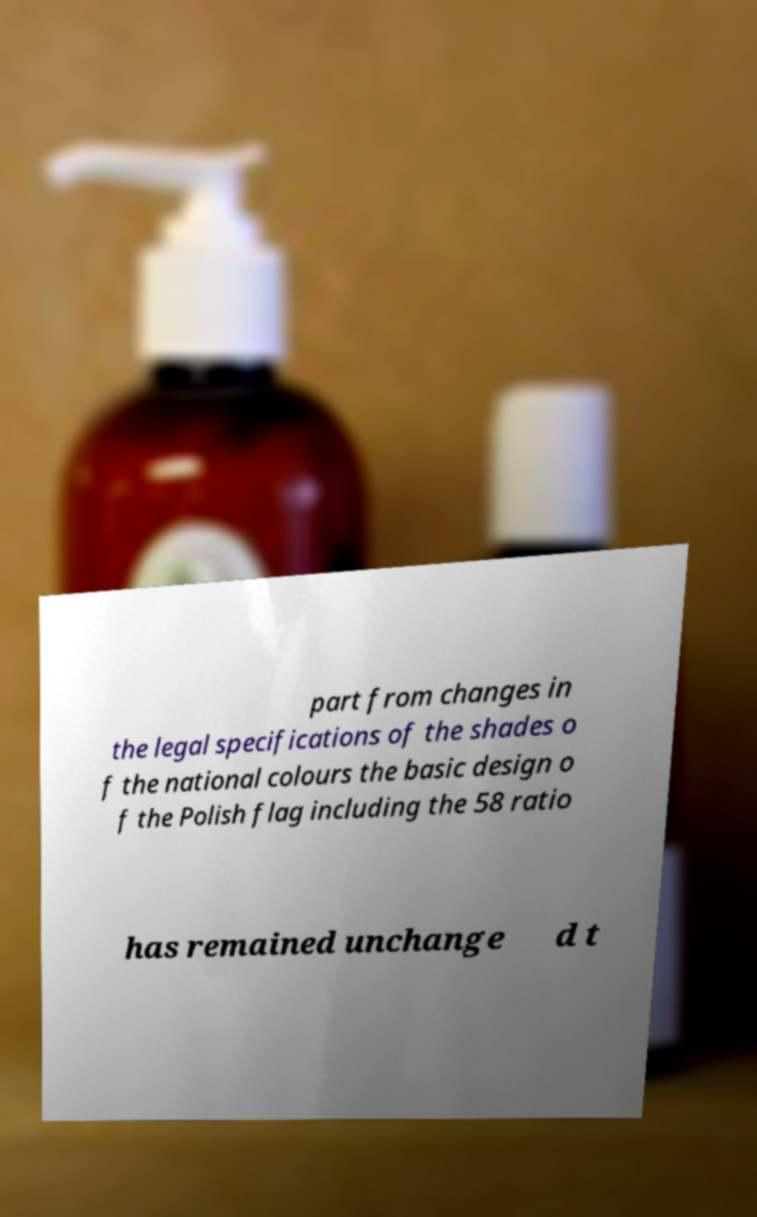I need the written content from this picture converted into text. Can you do that? part from changes in the legal specifications of the shades o f the national colours the basic design o f the Polish flag including the 58 ratio has remained unchange d t 